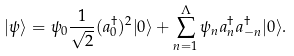<formula> <loc_0><loc_0><loc_500><loc_500>| \psi \rangle = \psi _ { 0 } \frac { 1 } { \sqrt { 2 } } ( a _ { 0 } ^ { \dagger } ) ^ { 2 } | 0 \rangle + \sum _ { n = 1 } ^ { \Lambda } \psi _ { n } a _ { n } ^ { \dagger } a _ { - n } ^ { \dagger } | 0 \rangle .</formula> 